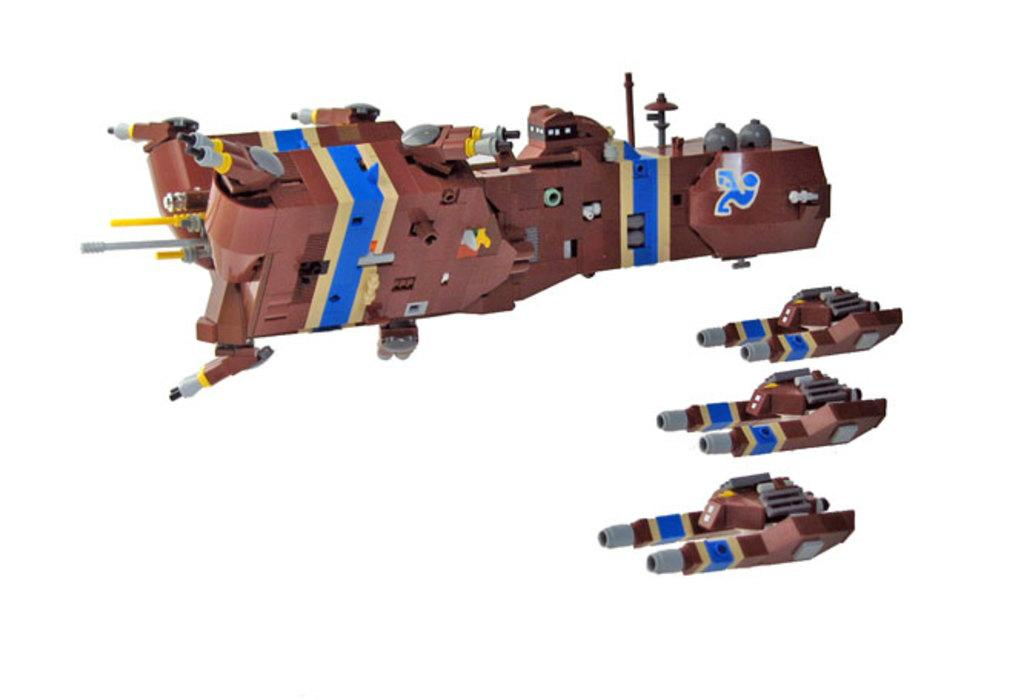What type of images are present in the picture? There are cartoon images in the picture. What color is the background of the picture? The background of the picture is white. Where is the flame located in the picture? There is no flame present in the picture; it features cartoon images and a white background. What type of box is being used to support the cartoon images? There is no box present in the picture, and the cartoon images are not being supported by any object. 